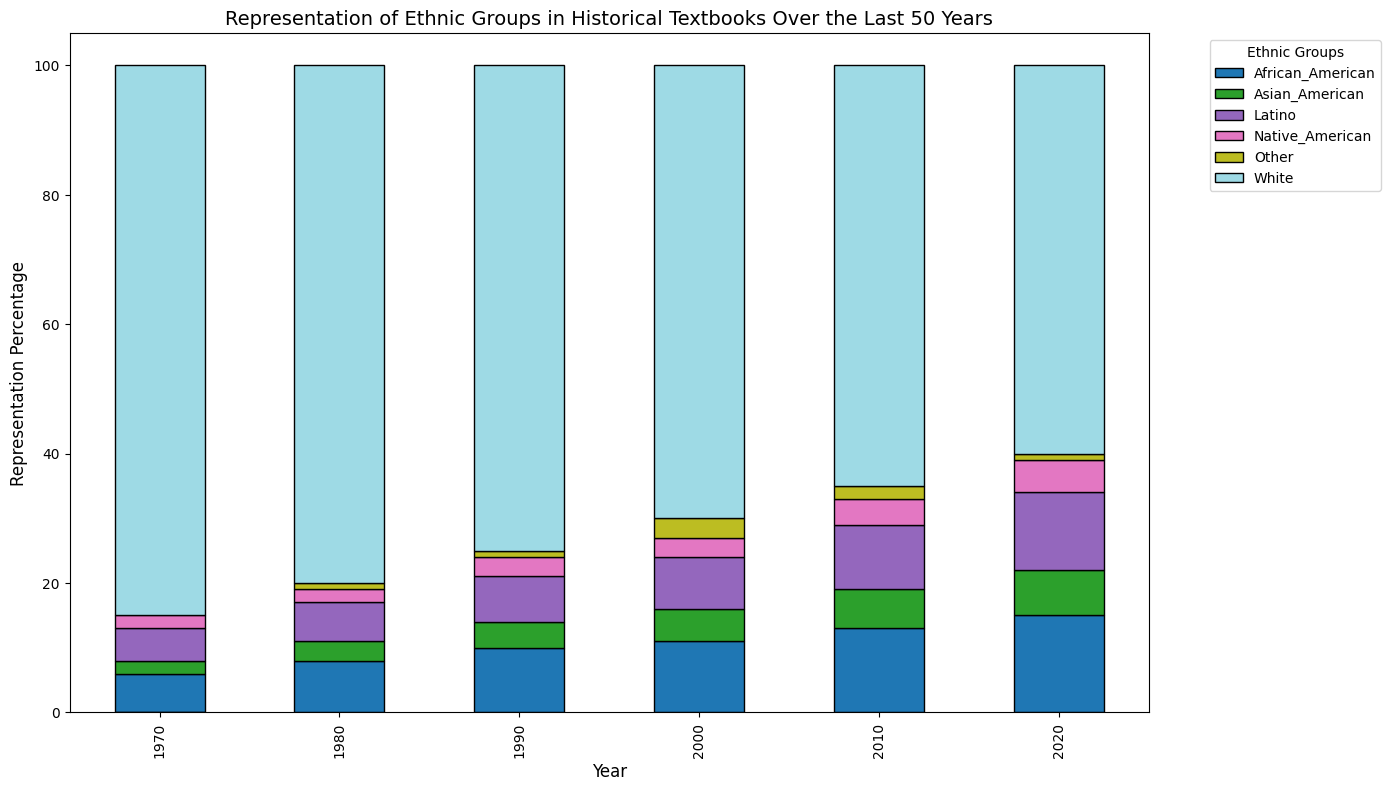what is the percentage difference in representation of African American groups between 1970 and 2020? To find the difference, subtract the representation percentage in 1970 from that in 2020: 15% - 6% = 9%.
Answer: 9% Which ethnic group shows the most noticeable decrease in representation from 1970 to 2020? By comparing the bar heights from 1970 to 2020, the White ethnic group shows a decrease from 85% to 60%, the most significant decrease.
Answer: White Is the representation of Asian American groups always increasing over the years? From the bars representing Asian American groups, the heights indicate a steady increase: 2% (1970) -> 3% (1980) -> 4% (1990) -> 5% (2000) -> 6% (2010) -> 7% (2020).
Answer: Yes What is the combined percentage of Native American representation in the years 1970 and 2020? Add the representation percentages for 1970 and 2020: 2% + 5% = 7%.
Answer: 7% Which ethnic group has the highest representation in 1980, according to the bar heights? The tallest bar in 1980 is for the White ethnic group at 80%.
Answer: White How does the representation of Latino groups in 1990 compare with that in 2020? Observe the bar heights for Latino groups: In 1990, it is 7%, and in 2020, it is 12%. Latino representation increased from 1990 to 2020.
Answer: Increased For which year is the combined representation of African American and Latino groups equal to 21%? In 2010, the African American representation is 13% and Latino 10%; their sum is 23%. In 2020, it is 15% + 12% = 27%. In 2000, it is 11% + 8% = 19%. In 1990, it is 10% + 7% = 17%. In 1980, it is 8% + 6% = 14%. Only in 1970, 6% + 5% = 11%. None of the years have a combined 21%.
Answer: None Which non-white ethnic group demonstrated the largest increase in representation from 1970 to 2020? Compare the differences: African Americans (15% - 6% = 9%), Native Americans (5% - 2% = 3%), Latinos (12% - 5% = 7%), Asian Americans (7% - 2% = 5%). African American groups show the largest increase of 9%.
Answer: African American What is the ratio of white to non-white representation in 1990? Calculate the percentage of non-white groups in 1990: 100% - 75% = 25% for non-white. The ratio is 75% (white) to 25% (non-white), which simplifies to 3:1.
Answer: 3:1 